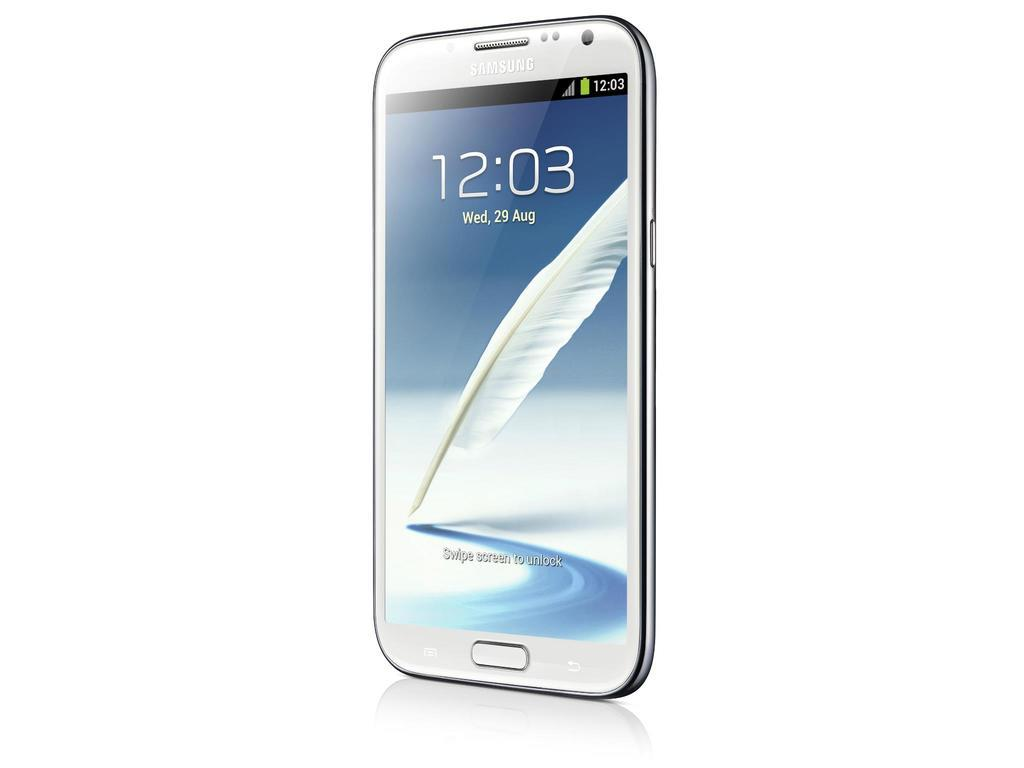<image>
Share a concise interpretation of the image provided. a phone with the time 12:03 on the screen. 